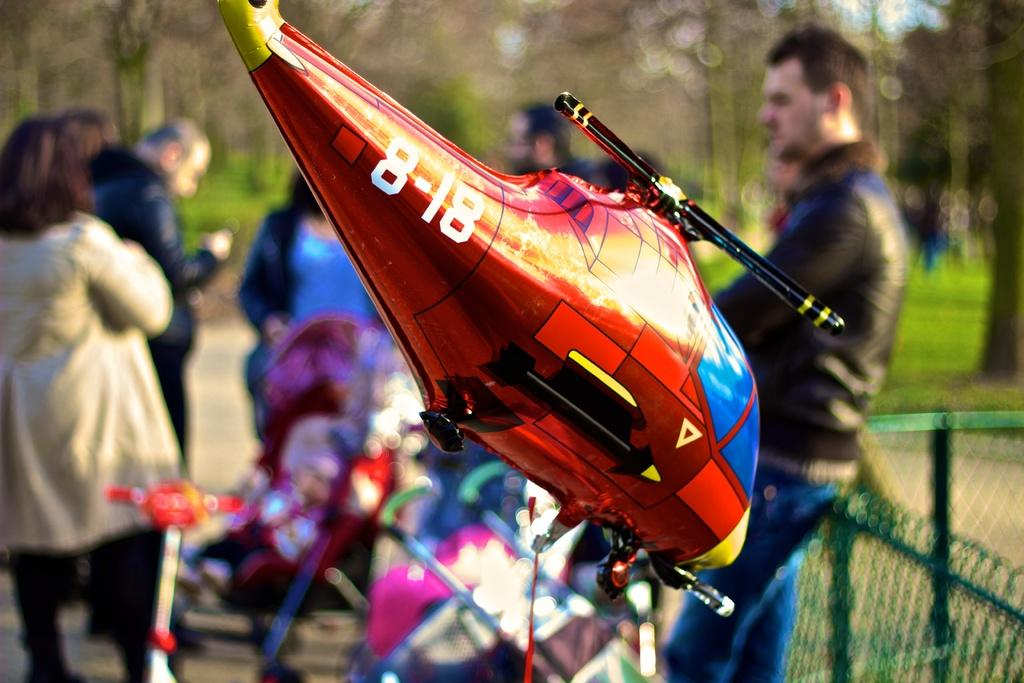<image>
Give a short and clear explanation of the subsequent image. The helicopter balloon has the numbers 8-18 on the tail. 